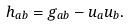<formula> <loc_0><loc_0><loc_500><loc_500>h _ { a b } = g _ { a b } - u _ { a } u _ { b } .</formula> 